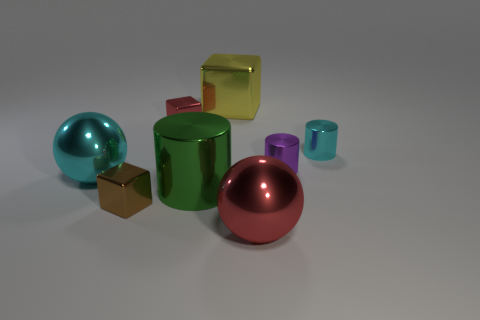There is a cyan metal thing that is behind the purple object; is its size the same as the small purple metal cylinder?
Make the answer very short. Yes. What is the shape of the cyan object that is right of the shiny sphere that is in front of the big green cylinder?
Your response must be concise. Cylinder. There is a cyan metal object right of the big ball in front of the small brown block; what size is it?
Offer a very short reply. Small. There is a large thing behind the purple shiny object; what is its color?
Your answer should be very brief. Yellow. What is the size of the cyan cylinder that is the same material as the big yellow object?
Your answer should be compact. Small. What number of other shiny objects have the same shape as the yellow thing?
Provide a short and direct response. 2. There is a yellow object that is the same size as the cyan sphere; what is its material?
Keep it short and to the point. Metal. Are there any other big cyan spheres made of the same material as the large cyan ball?
Offer a terse response. No. The tiny object that is behind the purple object and to the right of the large red metal object is what color?
Your answer should be very brief. Cyan. There is a ball that is left of the red metallic thing that is in front of the cyan metal thing right of the small red shiny thing; what is its material?
Ensure brevity in your answer.  Metal. 